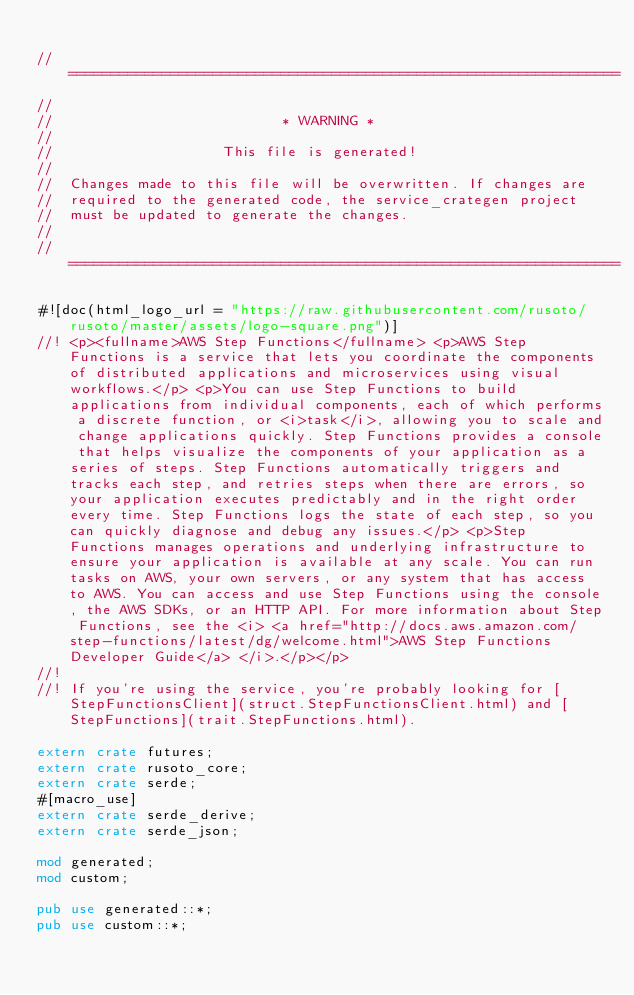Convert code to text. <code><loc_0><loc_0><loc_500><loc_500><_Rust_>
// =================================================================
//
//                           * WARNING *
//
//                    This file is generated!
//
//  Changes made to this file will be overwritten. If changes are
//  required to the generated code, the service_crategen project
//  must be updated to generate the changes.
//
// =================================================================

#![doc(html_logo_url = "https://raw.githubusercontent.com/rusoto/rusoto/master/assets/logo-square.png")]
//! <p><fullname>AWS Step Functions</fullname> <p>AWS Step Functions is a service that lets you coordinate the components of distributed applications and microservices using visual workflows.</p> <p>You can use Step Functions to build applications from individual components, each of which performs a discrete function, or <i>task</i>, allowing you to scale and change applications quickly. Step Functions provides a console that helps visualize the components of your application as a series of steps. Step Functions automatically triggers and tracks each step, and retries steps when there are errors, so your application executes predictably and in the right order every time. Step Functions logs the state of each step, so you can quickly diagnose and debug any issues.</p> <p>Step Functions manages operations and underlying infrastructure to ensure your application is available at any scale. You can run tasks on AWS, your own servers, or any system that has access to AWS. You can access and use Step Functions using the console, the AWS SDKs, or an HTTP API. For more information about Step Functions, see the <i> <a href="http://docs.aws.amazon.com/step-functions/latest/dg/welcome.html">AWS Step Functions Developer Guide</a> </i>.</p></p>
//!
//! If you're using the service, you're probably looking for [StepFunctionsClient](struct.StepFunctionsClient.html) and [StepFunctions](trait.StepFunctions.html).

extern crate futures;
extern crate rusoto_core;
extern crate serde;
#[macro_use]
extern crate serde_derive;
extern crate serde_json;

mod generated;
mod custom;

pub use generated::*;
pub use custom::*;
            
</code> 